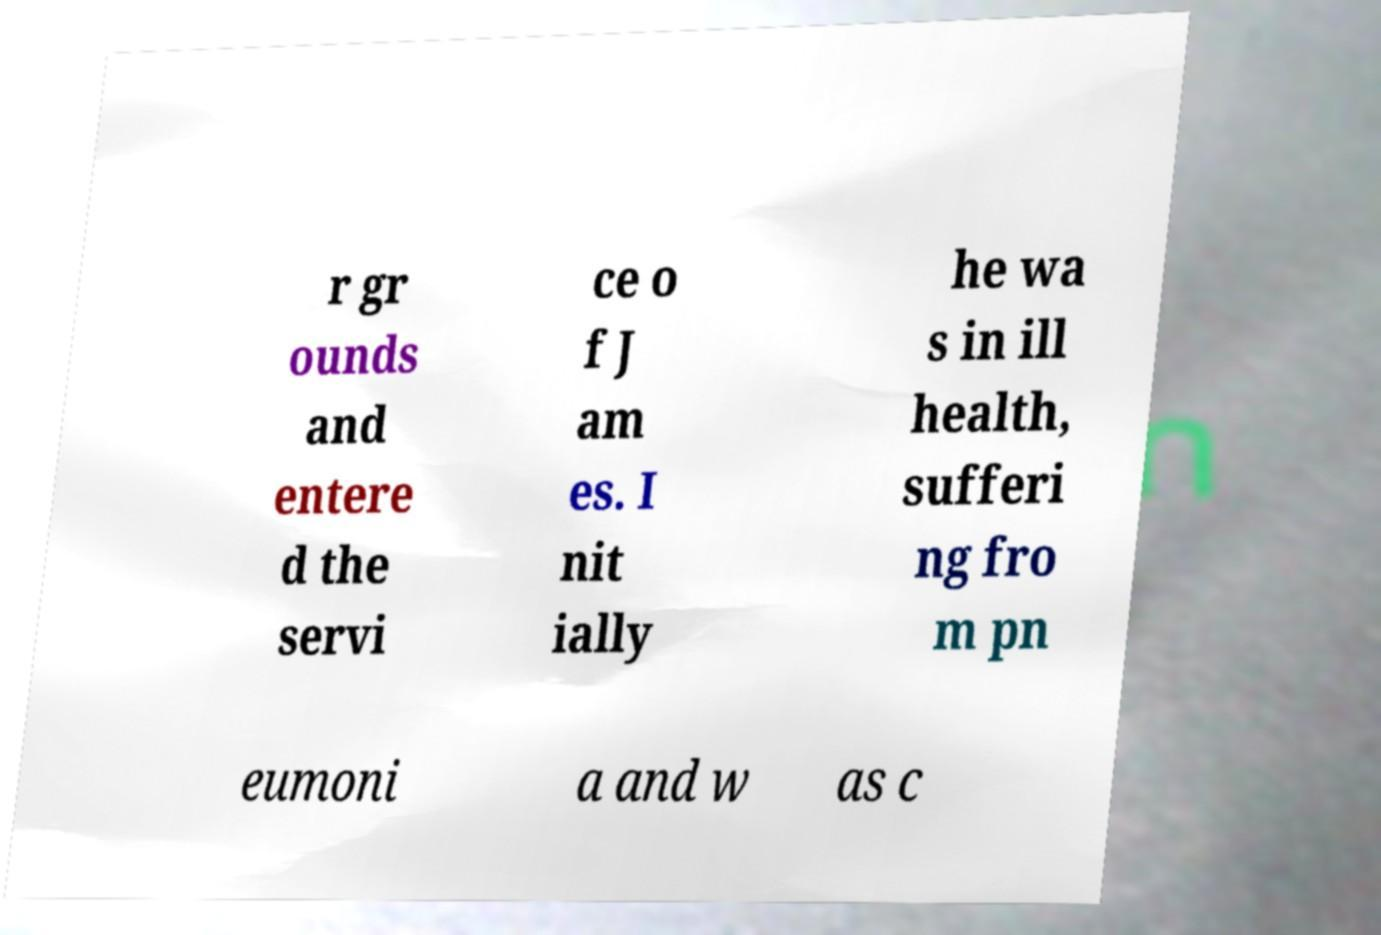Could you extract and type out the text from this image? r gr ounds and entere d the servi ce o f J am es. I nit ially he wa s in ill health, sufferi ng fro m pn eumoni a and w as c 